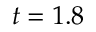Convert formula to latex. <formula><loc_0><loc_0><loc_500><loc_500>t = 1 . 8</formula> 